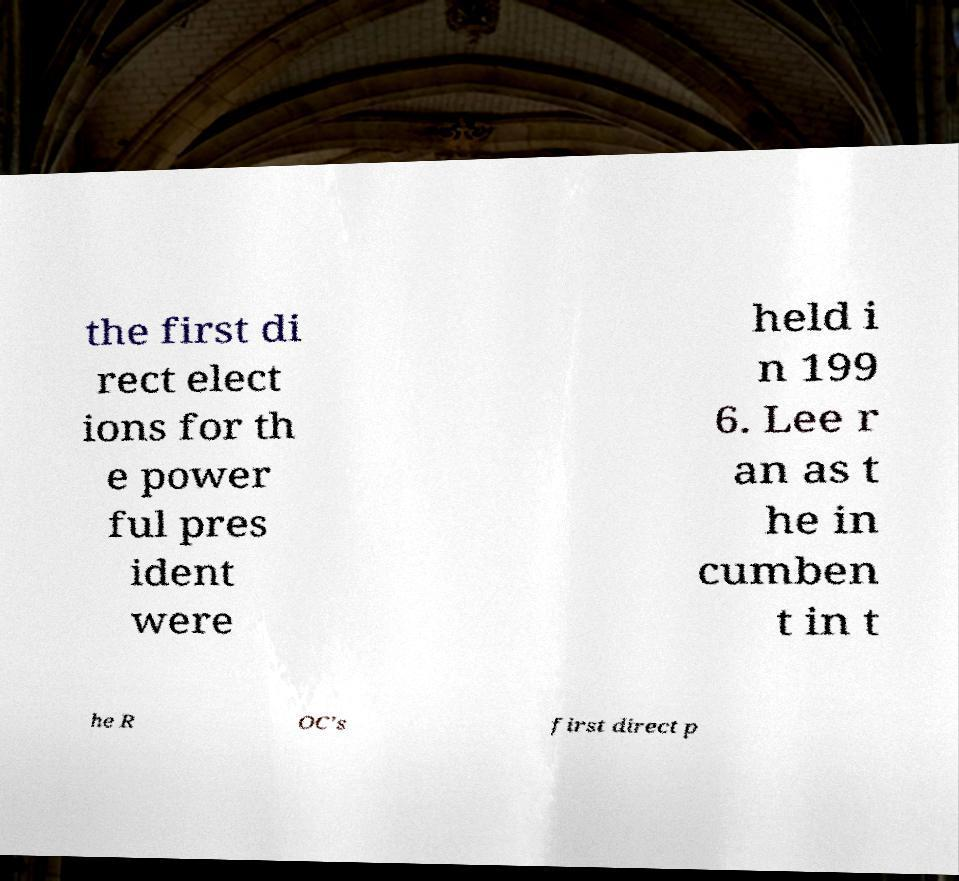I need the written content from this picture converted into text. Can you do that? the first di rect elect ions for th e power ful pres ident were held i n 199 6. Lee r an as t he in cumben t in t he R OC's first direct p 